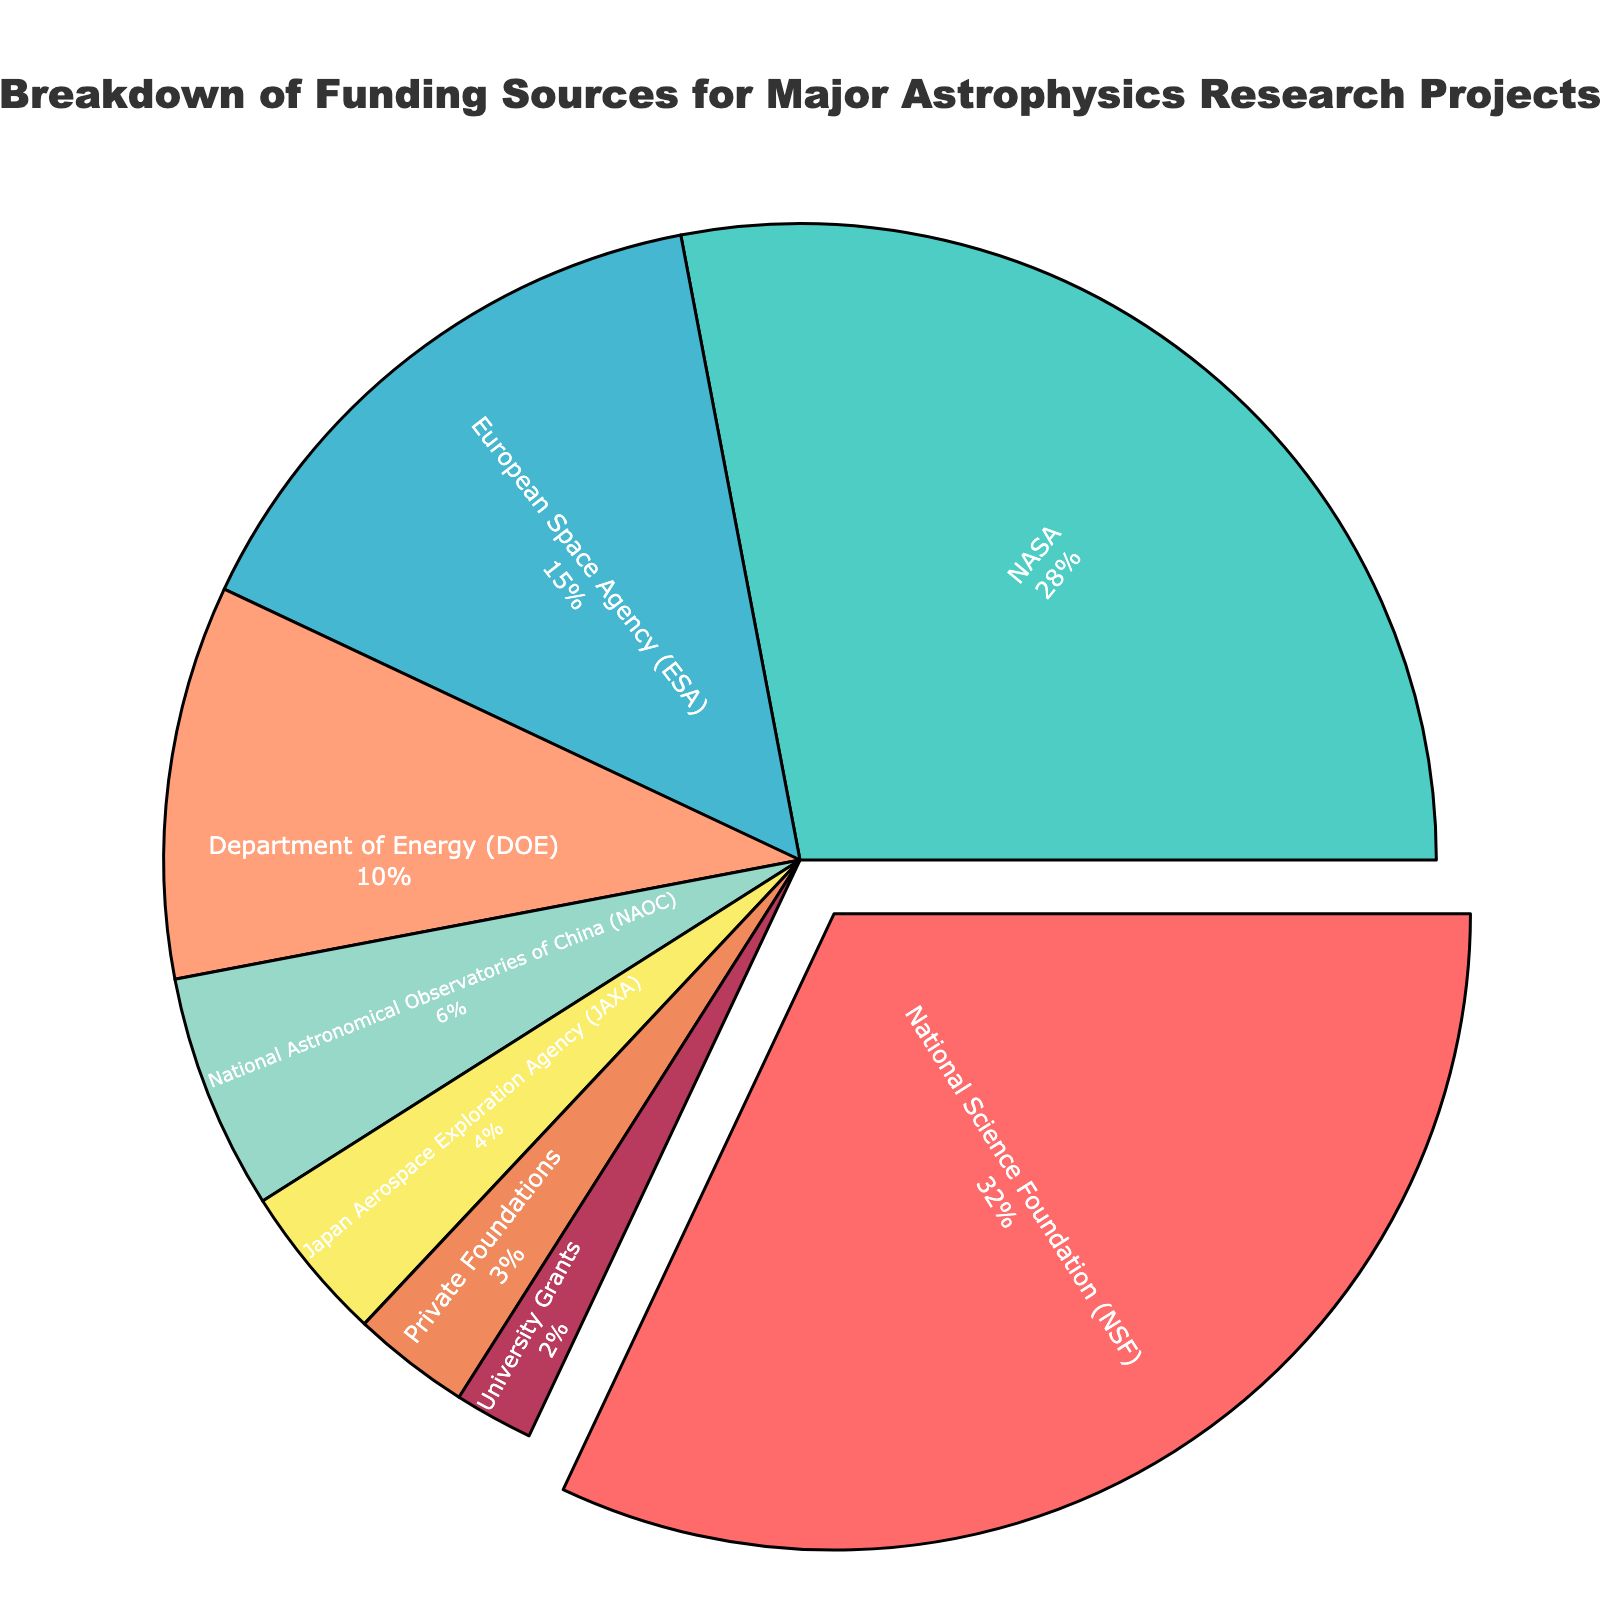What percentage of the funding is provided by NASA? Locate the segment labeled "NASA." The percentage value is written on the segment itself.
Answer: 28% Which funding source contributes the least to major astrophysics research projects? Identify the smallest segment in the pie chart, and check the corresponding label.
Answer: University Grants How much higher is the funding from National Science Foundation (NSF) compared to Department of Energy (DOE)? Find the percentages for both NSF and DOE, then subtract DOE's percentage from NSF's. NSF is 32% and DOE is 10%. 32% - 10% = 22%
Answer: 22% Are combined contributions from European Space Agency (ESA) and National Astronomical Observatories of China (NAOC) more than that from NASA? Sum up the percentages for ESA and NAOC, then compare the result with NASA's percentage. ESA is 15% and NAOC is 6%. 15% + 6% = 21%. NASA's is 28%, hence 21% < 28%
Answer: No What is the combined percentage of funding from private foundations and university grants? Add up the percentages for private foundations and university grants. Private foundations is 3% and university grants is 2%. 3% + 2% = 5%
Answer: 5% Which segment is highlighted in the pie chart? Identify the segment that is visually pulled out from the pie chart.
Answer: National Science Foundation (NSF) How much more funding does the Japan Aerospace Exploration Agency (JAXA) need to match the contribution of the European Space Agency (ESA)? Subtract the percentage of JAXA from ESA’s. ESA is 15% and JAXA is 4%. 15% - 4% = 11%
Answer: 11% Which funding source is represented by the green segment in the pie chart? Refer to the pie chart segment colored in green and read its corresponding label.
Answer: JAPAN Aerospace Exploration Agency (JAXA) What is the difference between the highest and the lowest funding contributions? Identify the highest and lowest values from the pie chart and calculate the difference. Highest is NSF at 32% and lowest is University Grants at 2%. 32% - 2% = 30%
Answer: 30% Is the Department of Energy (DOE) contribution at least half of the National Science Foundation (NSF) contribution? Compare the percentage of DOE to half of NSF’s percentage. NSF is 32%, half of NSF is 16%, DOE is 10%. 10% < 16%
Answer: No 